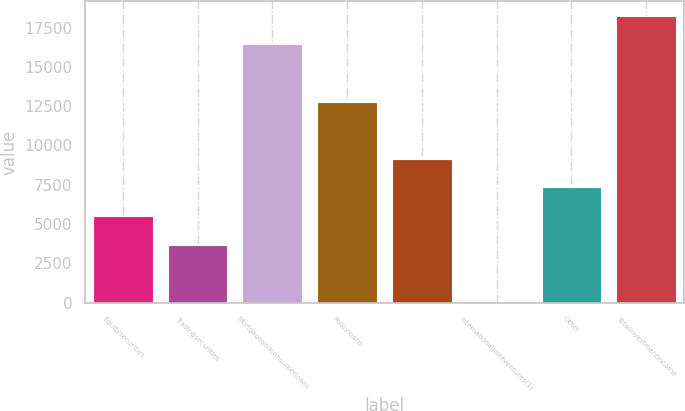Convert chart to OTSL. <chart><loc_0><loc_0><loc_500><loc_500><bar_chart><fcel>Equitysecurities<fcel>Tradingsecurities<fcel>Mortgageandconsumerloans<fcel>Policyloans<fcel>Unnamed: 4<fcel>Internationaljointventures(1)<fcel>Other<fcel>Totalinvestmentincome<nl><fcel>5506.3<fcel>3685.2<fcel>16432.9<fcel>12790.7<fcel>9148.5<fcel>43<fcel>7327.4<fcel>18254<nl></chart> 